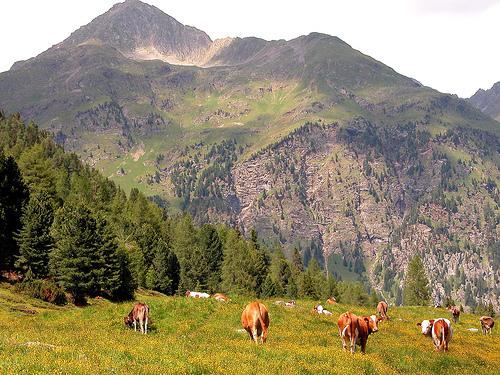How many species can be seen here of mammals?

Choices:
A) one
B) four
C) five
D) nine one 